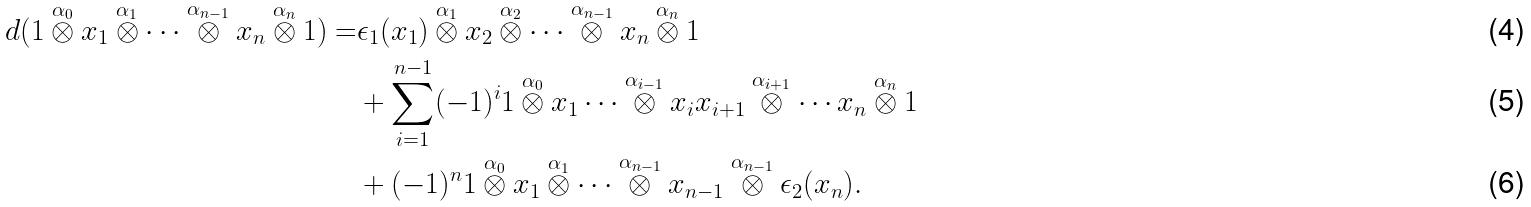<formula> <loc_0><loc_0><loc_500><loc_500>d ( 1 \overset { \alpha _ { 0 } } \otimes x _ { 1 } \overset { \alpha _ { 1 } } \otimes \cdots \overset { \alpha _ { n - 1 } } \otimes x _ { n } \overset { \alpha _ { n } } \otimes 1 ) = & \epsilon _ { 1 } ( x _ { 1 } ) \overset { \alpha _ { 1 } } \otimes x _ { 2 } \overset { \alpha _ { 2 } } \otimes \cdots \overset { \alpha _ { n - 1 } } \otimes x _ { n } \overset { \alpha _ { n } } \otimes 1 \\ & + \sum _ { i = 1 } ^ { n - 1 } ( - 1 ) ^ { i } 1 \overset { \alpha _ { 0 } } \otimes x _ { 1 } \cdots \overset { \alpha _ { i - 1 } } \otimes x _ { i } x _ { i + 1 } \overset { \alpha _ { i + 1 } } \otimes \cdots x _ { n } \overset { \alpha _ { n } } \otimes 1 \\ & + ( - 1 ) ^ { n } 1 \overset { \alpha _ { 0 } } \otimes x _ { 1 } \overset { \alpha _ { 1 } } \otimes \cdots \overset { \alpha _ { n - 1 } } \otimes x _ { n - 1 } \overset { \alpha _ { n - 1 } } \otimes \epsilon _ { 2 } ( x _ { n } ) .</formula> 